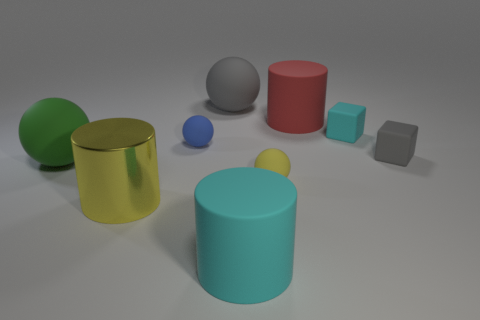Are there more tiny matte balls than yellow rubber spheres?
Provide a short and direct response. Yes. Is the material of the big cyan cylinder the same as the green sphere?
Your answer should be very brief. Yes. What number of tiny yellow things are made of the same material as the red object?
Your answer should be compact. 1. Do the gray sphere and the cyan rubber object that is behind the yellow rubber thing have the same size?
Provide a succinct answer. No. There is a big cylinder that is both in front of the small yellow ball and to the right of the metal object; what color is it?
Ensure brevity in your answer.  Cyan. There is a large cylinder behind the large green rubber thing; is there a matte object that is to the left of it?
Provide a short and direct response. Yes. Are there an equal number of gray matte spheres in front of the tiny cyan thing and tiny brown rubber things?
Ensure brevity in your answer.  Yes. There is a cyan matte thing behind the rubber block that is in front of the small cyan matte thing; how many cylinders are on the left side of it?
Your answer should be very brief. 3. Is there a gray matte ball that has the same size as the blue matte object?
Keep it short and to the point. No. Is the number of green things that are on the right side of the large yellow metallic cylinder less than the number of matte cylinders?
Provide a succinct answer. Yes. 